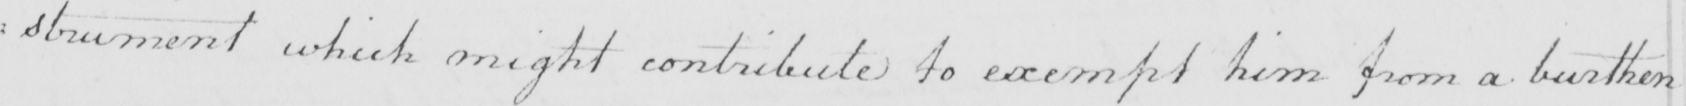Please provide the text content of this handwritten line. : strument which might contribute to exempt him from a burthen 